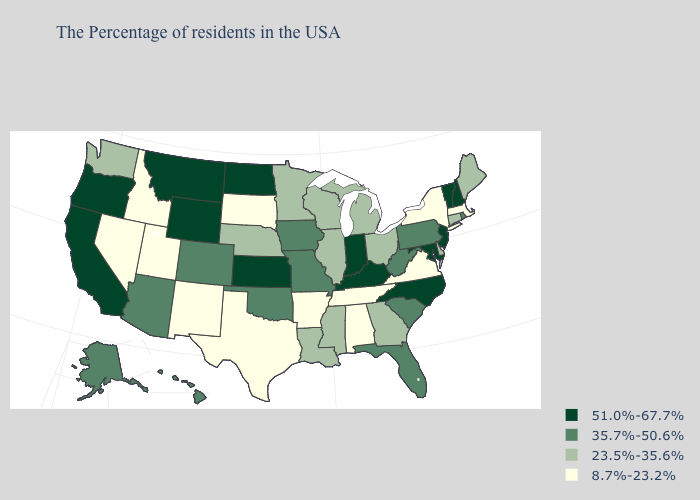What is the lowest value in the USA?
Answer briefly. 8.7%-23.2%. What is the highest value in the USA?
Quick response, please. 51.0%-67.7%. What is the value of Nevada?
Keep it brief. 8.7%-23.2%. Name the states that have a value in the range 51.0%-67.7%?
Quick response, please. New Hampshire, Vermont, New Jersey, Maryland, North Carolina, Kentucky, Indiana, Kansas, North Dakota, Wyoming, Montana, California, Oregon. Name the states that have a value in the range 8.7%-23.2%?
Give a very brief answer. Massachusetts, New York, Virginia, Alabama, Tennessee, Arkansas, Texas, South Dakota, New Mexico, Utah, Idaho, Nevada. What is the value of New Mexico?
Be succinct. 8.7%-23.2%. Name the states that have a value in the range 51.0%-67.7%?
Be succinct. New Hampshire, Vermont, New Jersey, Maryland, North Carolina, Kentucky, Indiana, Kansas, North Dakota, Wyoming, Montana, California, Oregon. What is the value of Connecticut?
Keep it brief. 23.5%-35.6%. Which states hav the highest value in the MidWest?
Quick response, please. Indiana, Kansas, North Dakota. Does Maryland have the lowest value in the South?
Be succinct. No. Name the states that have a value in the range 8.7%-23.2%?
Give a very brief answer. Massachusetts, New York, Virginia, Alabama, Tennessee, Arkansas, Texas, South Dakota, New Mexico, Utah, Idaho, Nevada. Name the states that have a value in the range 23.5%-35.6%?
Keep it brief. Maine, Connecticut, Delaware, Ohio, Georgia, Michigan, Wisconsin, Illinois, Mississippi, Louisiana, Minnesota, Nebraska, Washington. Among the states that border Oregon , which have the lowest value?
Give a very brief answer. Idaho, Nevada. Which states have the highest value in the USA?
Quick response, please. New Hampshire, Vermont, New Jersey, Maryland, North Carolina, Kentucky, Indiana, Kansas, North Dakota, Wyoming, Montana, California, Oregon. Which states have the lowest value in the USA?
Keep it brief. Massachusetts, New York, Virginia, Alabama, Tennessee, Arkansas, Texas, South Dakota, New Mexico, Utah, Idaho, Nevada. 